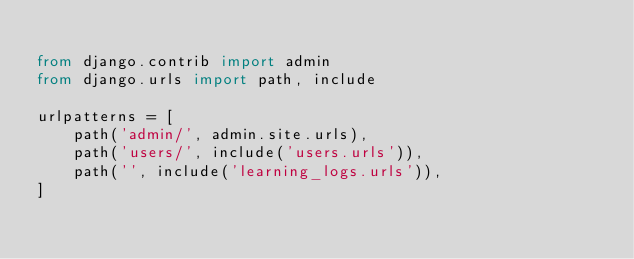<code> <loc_0><loc_0><loc_500><loc_500><_Python_>
from django.contrib import admin
from django.urls import path, include

urlpatterns = [
    path('admin/', admin.site.urls),
    path('users/', include('users.urls')),
    path('', include('learning_logs.urls')),
]
</code> 